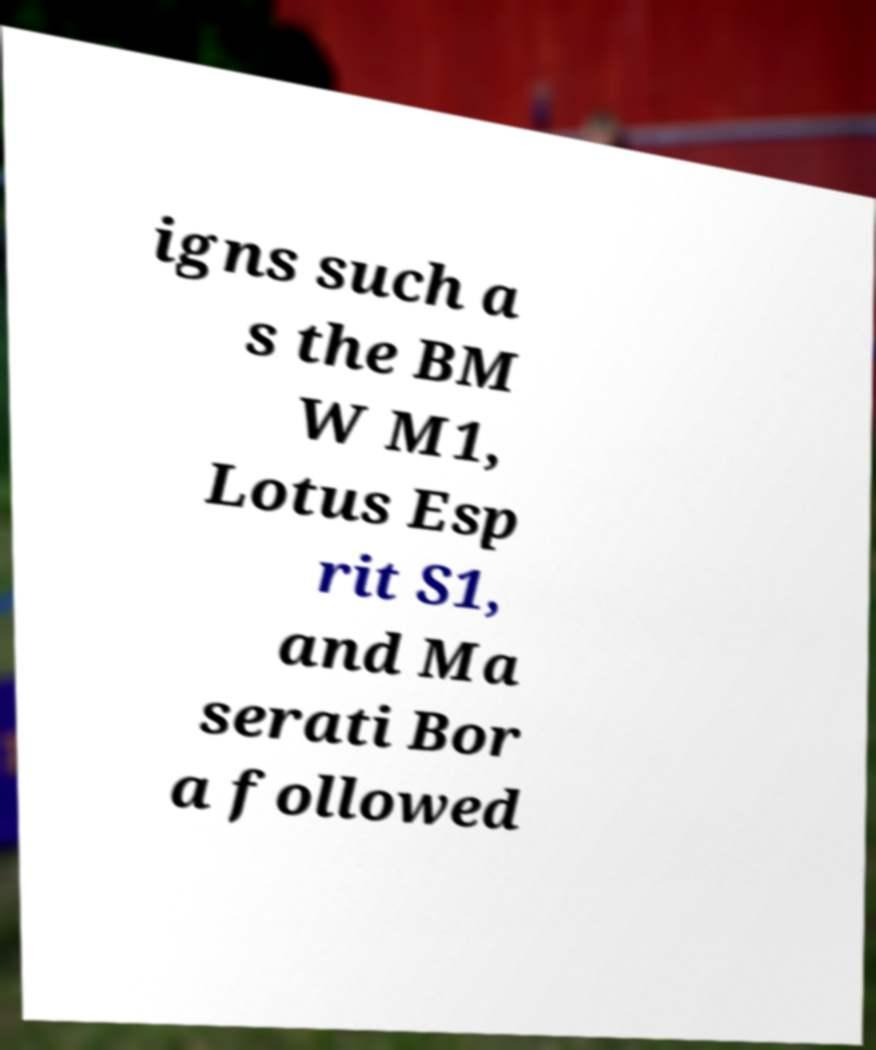Please identify and transcribe the text found in this image. igns such a s the BM W M1, Lotus Esp rit S1, and Ma serati Bor a followed 